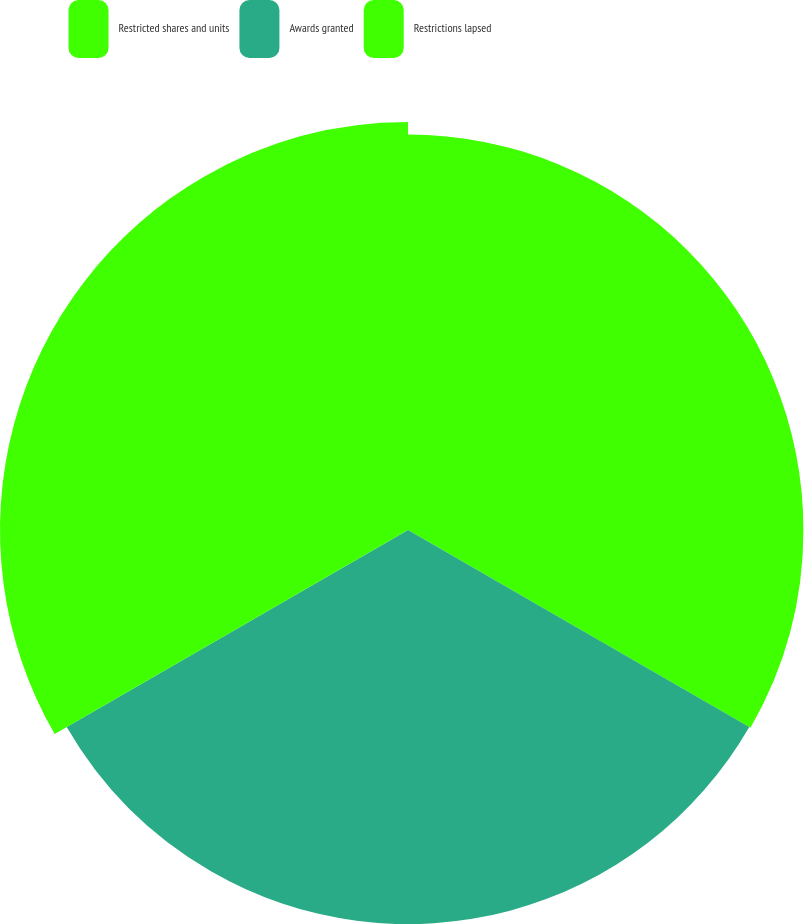Convert chart. <chart><loc_0><loc_0><loc_500><loc_500><pie_chart><fcel>Restricted shares and units<fcel>Awards granted<fcel>Restrictions lapsed<nl><fcel>33.02%<fcel>32.91%<fcel>34.07%<nl></chart> 